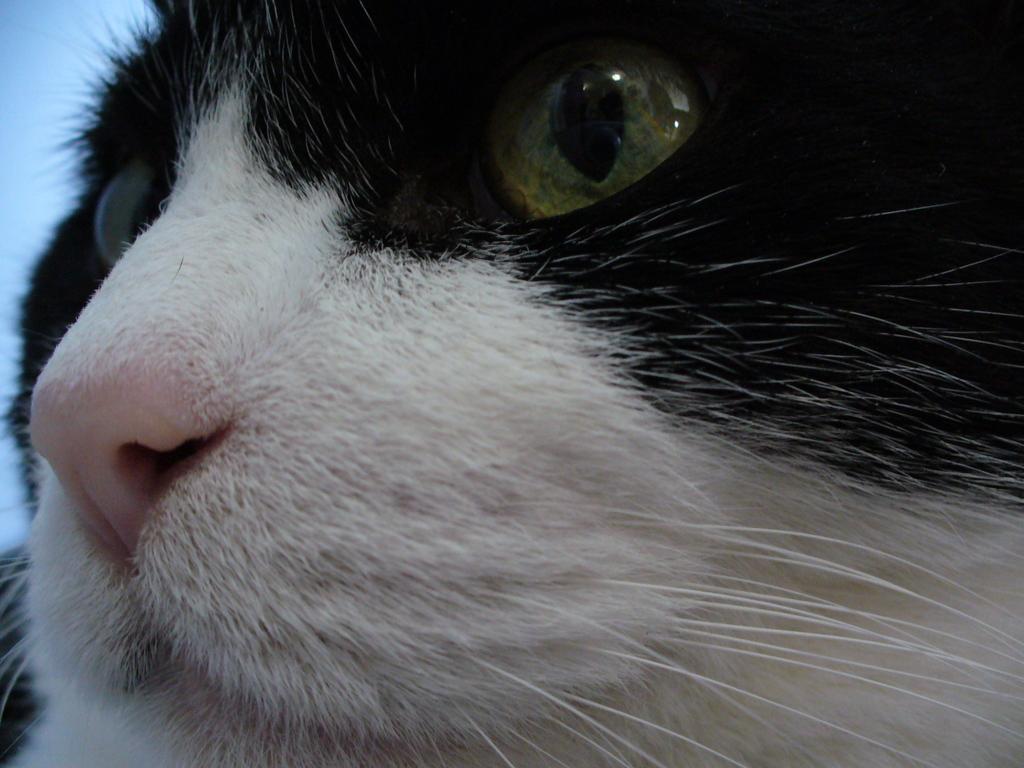Please provide a concise description of this image. In this image I can see a cat face. In the background of the image it is in blue color.   